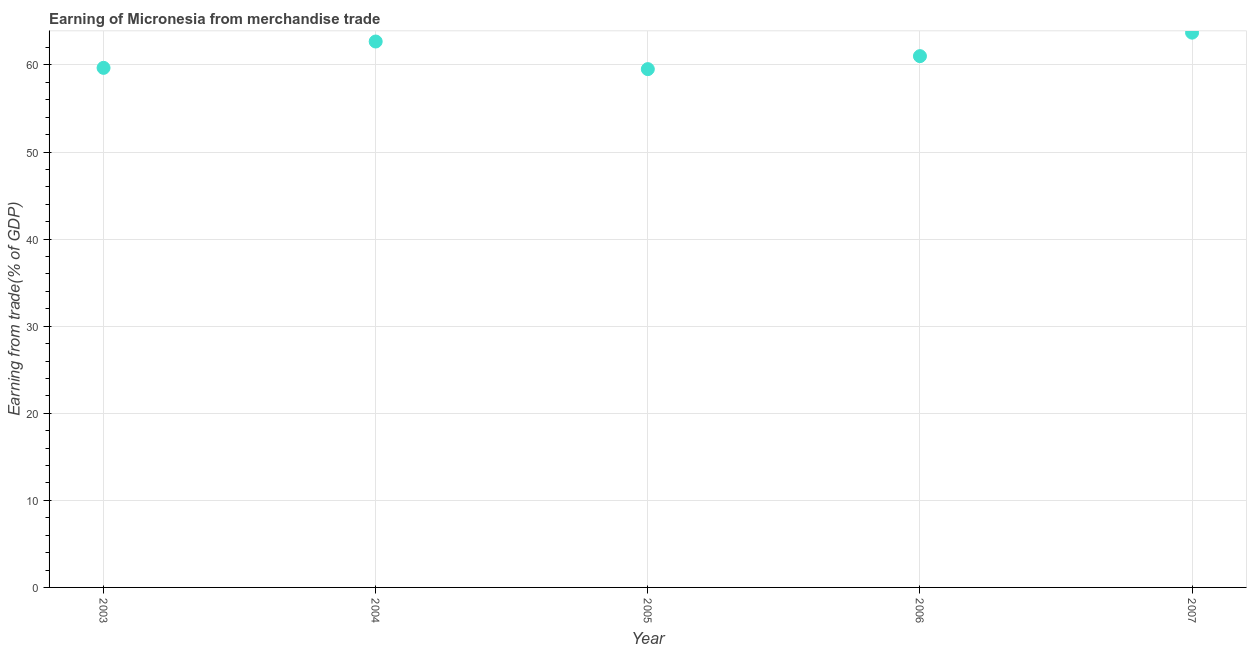What is the earning from merchandise trade in 2003?
Make the answer very short. 59.67. Across all years, what is the maximum earning from merchandise trade?
Ensure brevity in your answer.  63.71. Across all years, what is the minimum earning from merchandise trade?
Make the answer very short. 59.52. In which year was the earning from merchandise trade maximum?
Give a very brief answer. 2007. What is the sum of the earning from merchandise trade?
Make the answer very short. 306.61. What is the difference between the earning from merchandise trade in 2004 and 2005?
Your answer should be compact. 3.17. What is the average earning from merchandise trade per year?
Keep it short and to the point. 61.32. What is the median earning from merchandise trade?
Keep it short and to the point. 61.01. Do a majority of the years between 2003 and 2006 (inclusive) have earning from merchandise trade greater than 18 %?
Your answer should be very brief. Yes. What is the ratio of the earning from merchandise trade in 2003 to that in 2005?
Make the answer very short. 1. What is the difference between the highest and the second highest earning from merchandise trade?
Give a very brief answer. 1.02. What is the difference between the highest and the lowest earning from merchandise trade?
Your answer should be compact. 4.19. Does the earning from merchandise trade monotonically increase over the years?
Your answer should be compact. No. How many dotlines are there?
Keep it short and to the point. 1. How many years are there in the graph?
Give a very brief answer. 5. Does the graph contain grids?
Give a very brief answer. Yes. What is the title of the graph?
Keep it short and to the point. Earning of Micronesia from merchandise trade. What is the label or title of the Y-axis?
Give a very brief answer. Earning from trade(% of GDP). What is the Earning from trade(% of GDP) in 2003?
Keep it short and to the point. 59.67. What is the Earning from trade(% of GDP) in 2004?
Provide a succinct answer. 62.69. What is the Earning from trade(% of GDP) in 2005?
Ensure brevity in your answer.  59.52. What is the Earning from trade(% of GDP) in 2006?
Provide a succinct answer. 61.01. What is the Earning from trade(% of GDP) in 2007?
Provide a short and direct response. 63.71. What is the difference between the Earning from trade(% of GDP) in 2003 and 2004?
Make the answer very short. -3.03. What is the difference between the Earning from trade(% of GDP) in 2003 and 2005?
Provide a succinct answer. 0.15. What is the difference between the Earning from trade(% of GDP) in 2003 and 2006?
Your answer should be compact. -1.34. What is the difference between the Earning from trade(% of GDP) in 2003 and 2007?
Provide a succinct answer. -4.04. What is the difference between the Earning from trade(% of GDP) in 2004 and 2005?
Ensure brevity in your answer.  3.17. What is the difference between the Earning from trade(% of GDP) in 2004 and 2006?
Your response must be concise. 1.68. What is the difference between the Earning from trade(% of GDP) in 2004 and 2007?
Keep it short and to the point. -1.02. What is the difference between the Earning from trade(% of GDP) in 2005 and 2006?
Give a very brief answer. -1.49. What is the difference between the Earning from trade(% of GDP) in 2005 and 2007?
Give a very brief answer. -4.19. What is the difference between the Earning from trade(% of GDP) in 2006 and 2007?
Provide a succinct answer. -2.7. What is the ratio of the Earning from trade(% of GDP) in 2003 to that in 2006?
Give a very brief answer. 0.98. What is the ratio of the Earning from trade(% of GDP) in 2003 to that in 2007?
Keep it short and to the point. 0.94. What is the ratio of the Earning from trade(% of GDP) in 2004 to that in 2005?
Offer a very short reply. 1.05. What is the ratio of the Earning from trade(% of GDP) in 2004 to that in 2006?
Offer a very short reply. 1.03. What is the ratio of the Earning from trade(% of GDP) in 2005 to that in 2007?
Ensure brevity in your answer.  0.93. What is the ratio of the Earning from trade(% of GDP) in 2006 to that in 2007?
Keep it short and to the point. 0.96. 